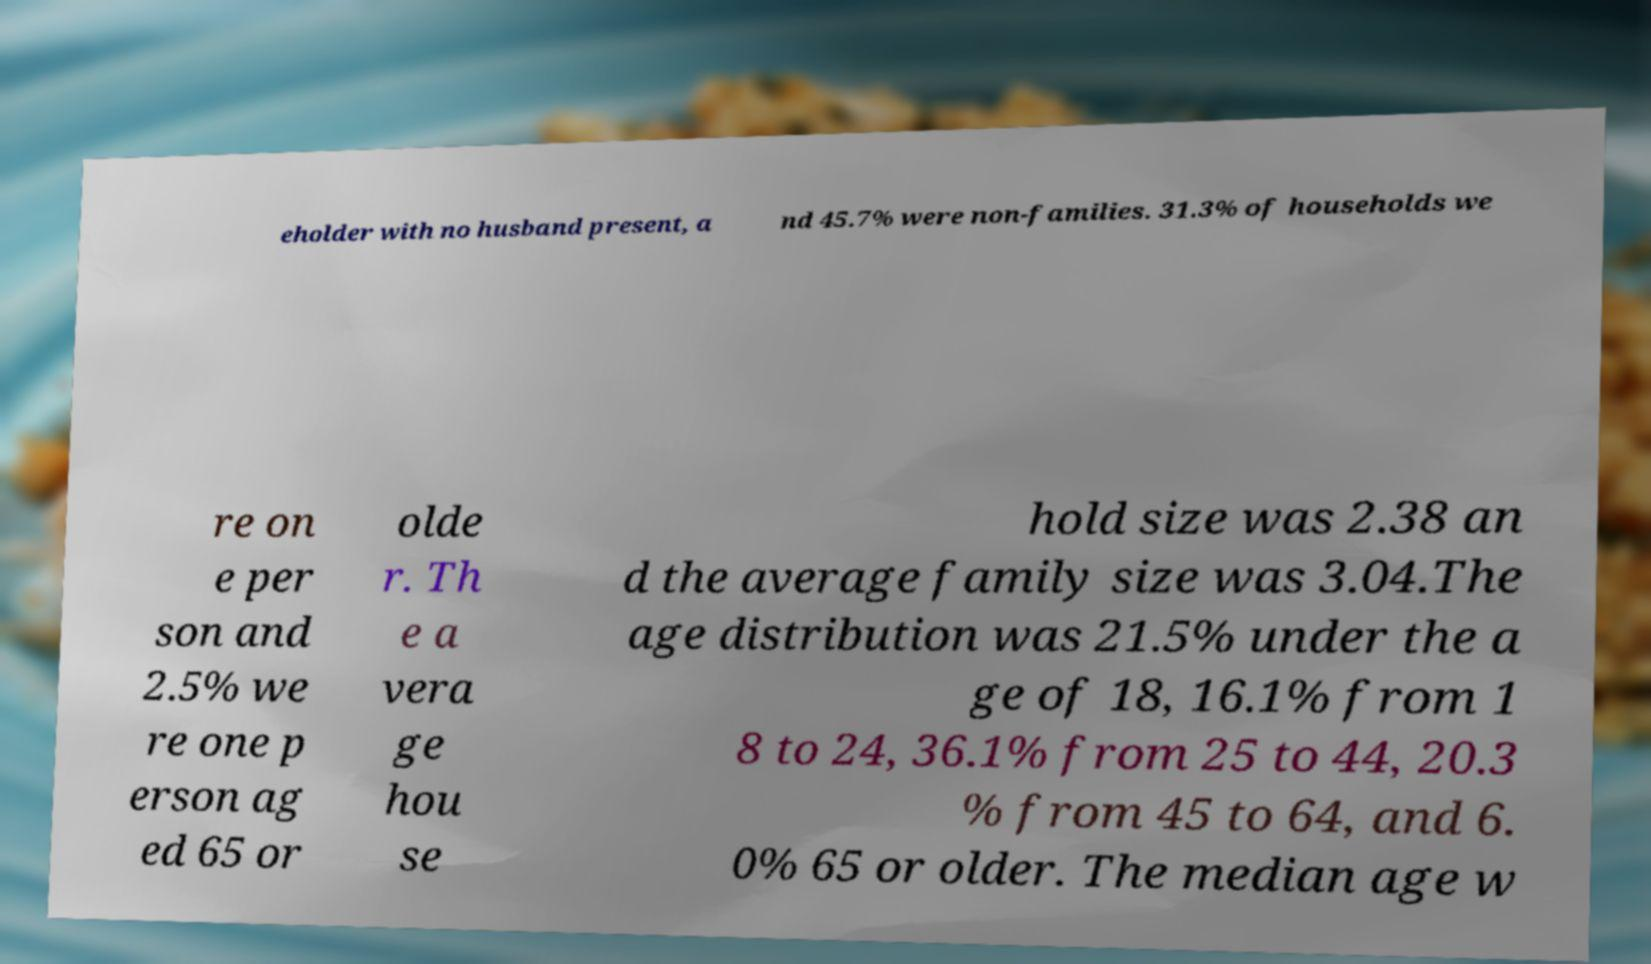Please identify and transcribe the text found in this image. eholder with no husband present, a nd 45.7% were non-families. 31.3% of households we re on e per son and 2.5% we re one p erson ag ed 65 or olde r. Th e a vera ge hou se hold size was 2.38 an d the average family size was 3.04.The age distribution was 21.5% under the a ge of 18, 16.1% from 1 8 to 24, 36.1% from 25 to 44, 20.3 % from 45 to 64, and 6. 0% 65 or older. The median age w 